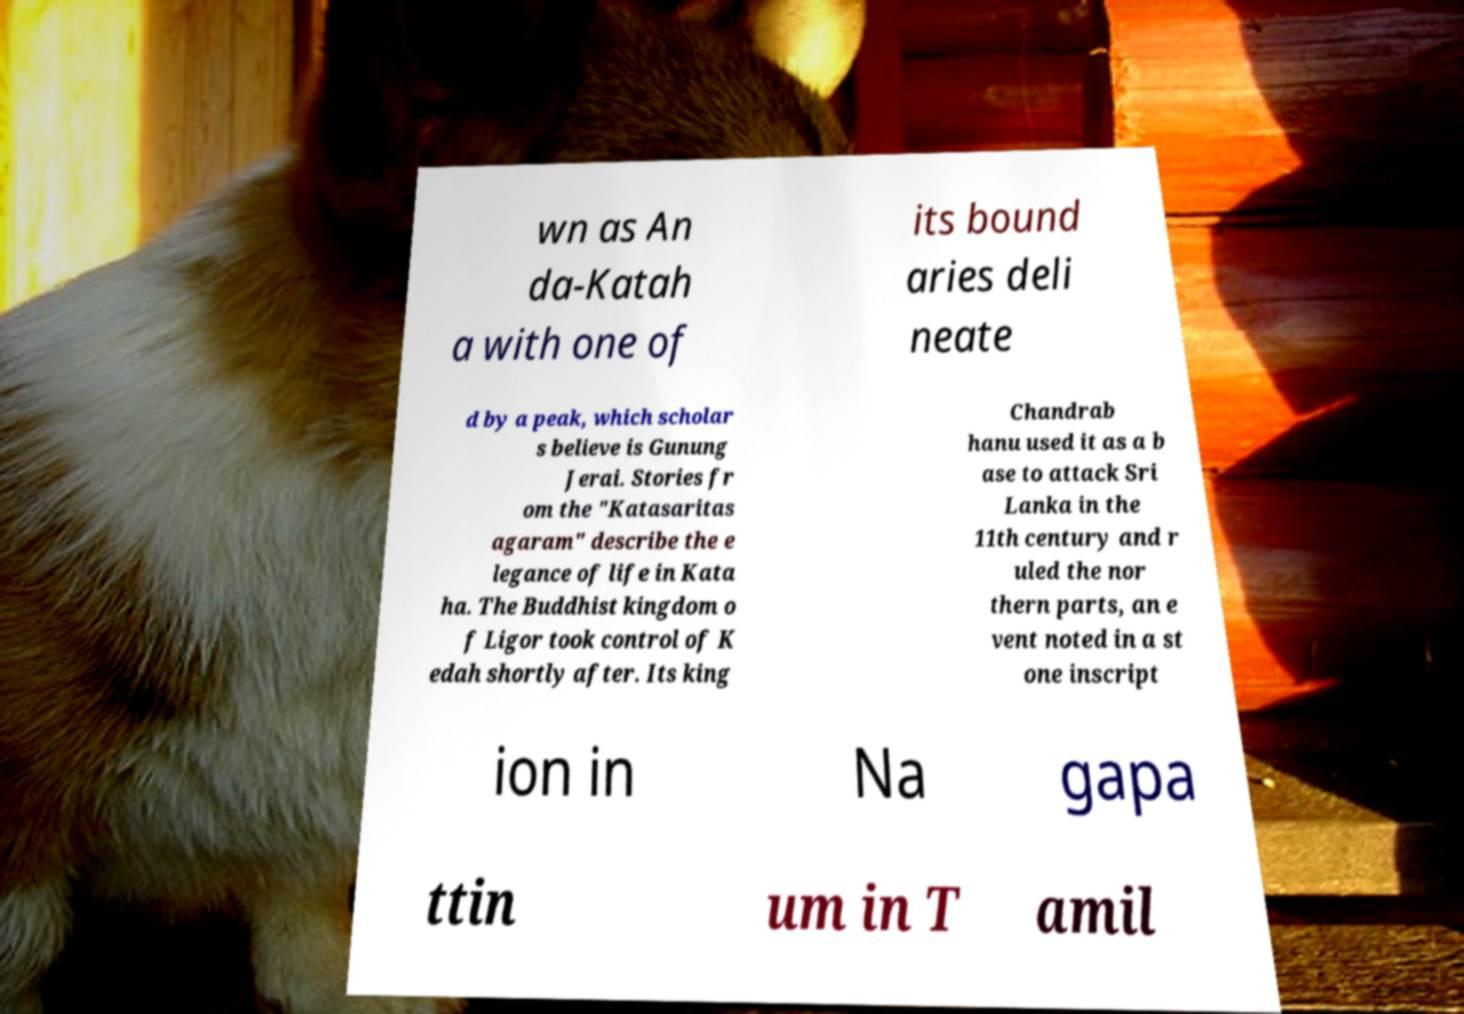Could you extract and type out the text from this image? wn as An da-Katah a with one of its bound aries deli neate d by a peak, which scholar s believe is Gunung Jerai. Stories fr om the "Katasaritas agaram" describe the e legance of life in Kata ha. The Buddhist kingdom o f Ligor took control of K edah shortly after. Its king Chandrab hanu used it as a b ase to attack Sri Lanka in the 11th century and r uled the nor thern parts, an e vent noted in a st one inscript ion in Na gapa ttin um in T amil 